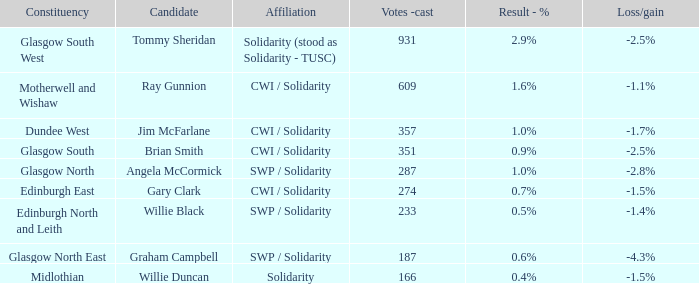For whom was the 0.4% result registered as a candidate? Willie Duncan. 